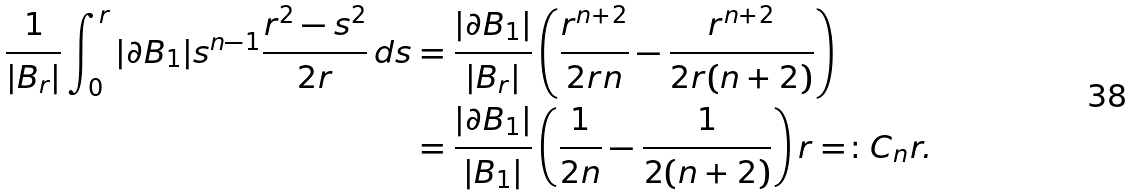Convert formula to latex. <formula><loc_0><loc_0><loc_500><loc_500>\frac { 1 } { | B _ { r } | } \int _ { 0 } ^ { r } | \partial B _ { 1 } | s ^ { n - 1 } \frac { r ^ { 2 } - s ^ { 2 } } { 2 r } \, d s & = \frac { | \partial B _ { 1 } | } { | B _ { r } | } \left ( \frac { r ^ { n + 2 } } { 2 r n } - \frac { r ^ { n + 2 } } { 2 r ( n + 2 ) } \right ) \\ & = \frac { | \partial B _ { 1 } | } { | B _ { 1 } | } \left ( \frac { 1 } { 2 n } - \frac { 1 } { 2 ( n + 2 ) } \right ) r = \colon C _ { n } r .</formula> 